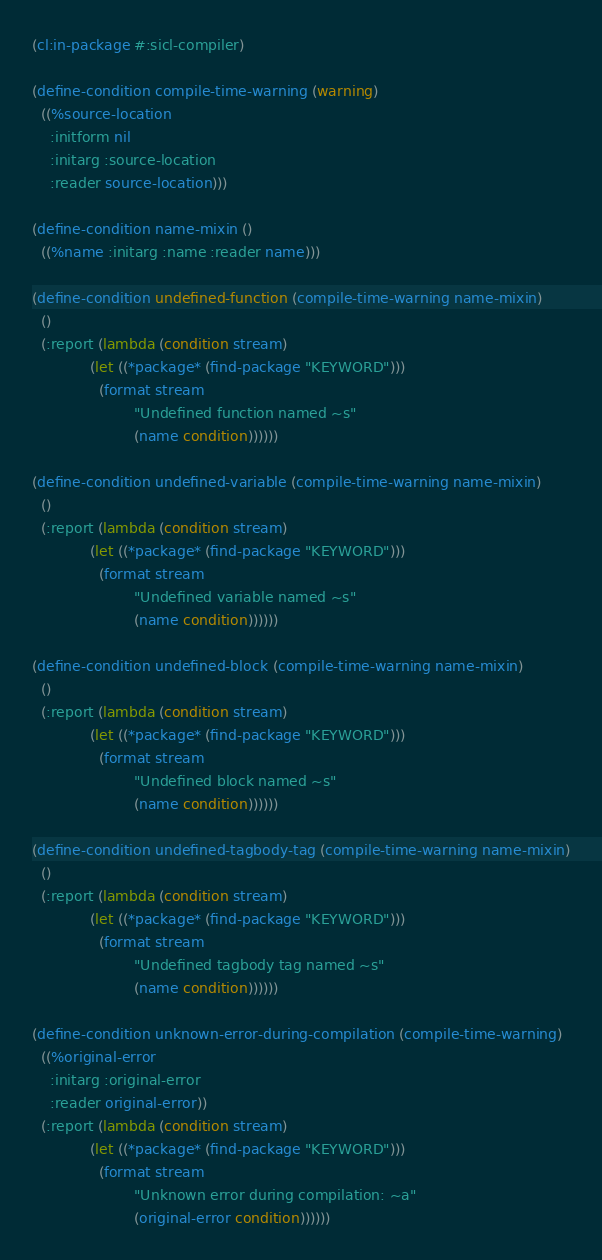<code> <loc_0><loc_0><loc_500><loc_500><_Lisp_>(cl:in-package #:sicl-compiler)

(define-condition compile-time-warning (warning)
  ((%source-location
    :initform nil
    :initarg :source-location
    :reader source-location)))

(define-condition name-mixin ()
  ((%name :initarg :name :reader name)))

(define-condition undefined-function (compile-time-warning name-mixin)
  ()
  (:report (lambda (condition stream)
             (let ((*package* (find-package "KEYWORD")))
               (format stream
                       "Undefined function named ~s"
                       (name condition))))))

(define-condition undefined-variable (compile-time-warning name-mixin)
  ()
  (:report (lambda (condition stream)
             (let ((*package* (find-package "KEYWORD")))
               (format stream
                       "Undefined variable named ~s"
                       (name condition))))))

(define-condition undefined-block (compile-time-warning name-mixin)
  ()
  (:report (lambda (condition stream)
             (let ((*package* (find-package "KEYWORD")))
               (format stream
                       "Undefined block named ~s"
                       (name condition))))))

(define-condition undefined-tagbody-tag (compile-time-warning name-mixin)
  ()
  (:report (lambda (condition stream)
             (let ((*package* (find-package "KEYWORD")))
               (format stream
                       "Undefined tagbody tag named ~s"
                       (name condition))))))

(define-condition unknown-error-during-compilation (compile-time-warning)
  ((%original-error
    :initarg :original-error
    :reader original-error))
  (:report (lambda (condition stream)
             (let ((*package* (find-package "KEYWORD")))
               (format stream
                       "Unknown error during compilation: ~a"
                       (original-error condition))))))
</code> 